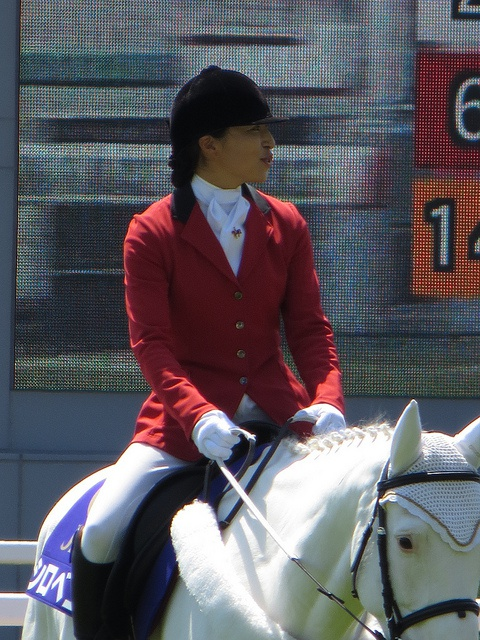Describe the objects in this image and their specific colors. I can see people in gray, black, maroon, white, and salmon tones, horse in blue, white, gray, and darkgray tones, and tie in blue and gray tones in this image. 